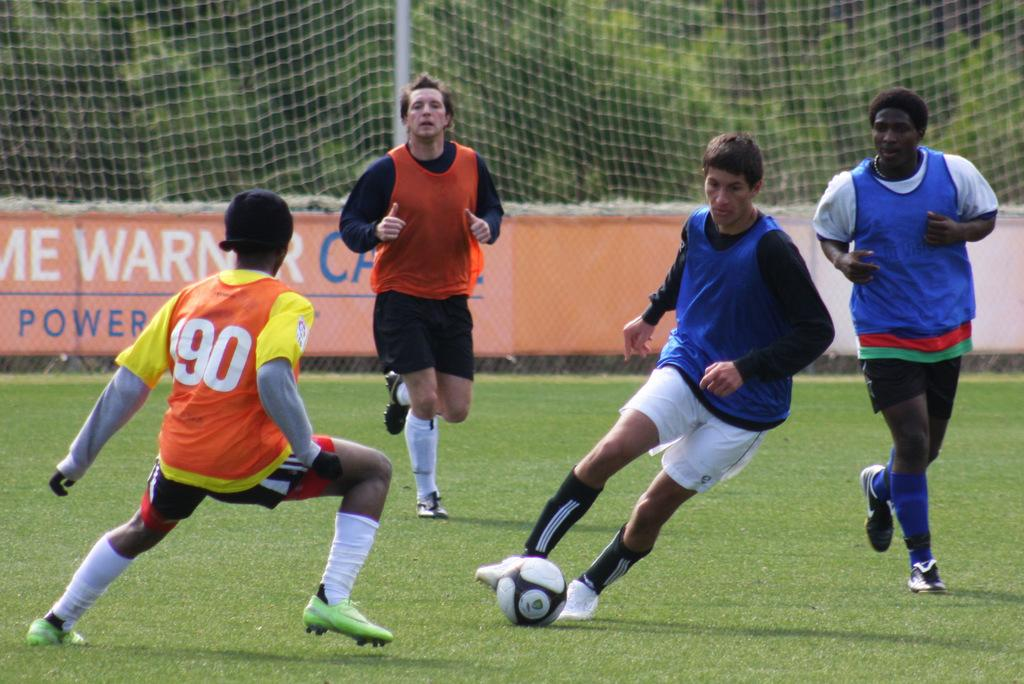<image>
Render a clear and concise summary of the photo. Several soccer players are engaged in a match, one of which wears number 90. 